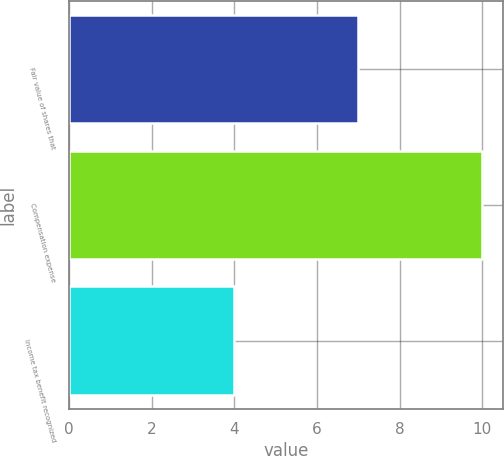<chart> <loc_0><loc_0><loc_500><loc_500><bar_chart><fcel>Fair value of shares that<fcel>Compensation expense<fcel>Income tax benefit recognized<nl><fcel>7<fcel>10<fcel>4<nl></chart> 